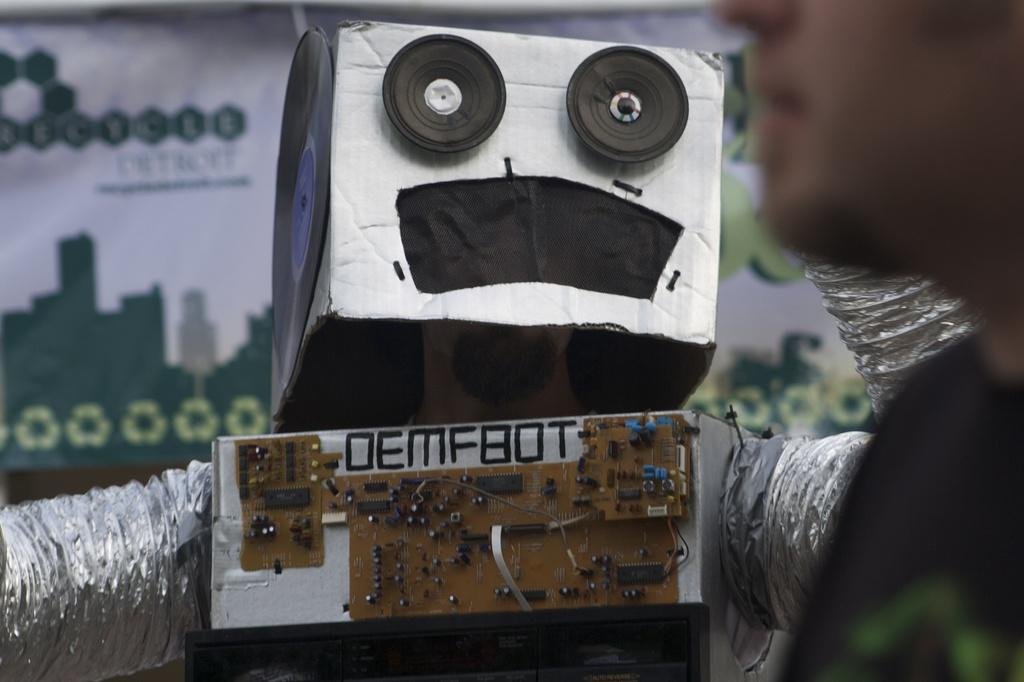Describe this image in one or two sentences. On the right side of the image we can see a person. Behind the person there is a robot. Behind the robot there's banner. 